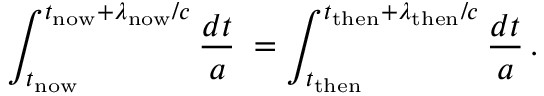Convert formula to latex. <formula><loc_0><loc_0><loc_500><loc_500>\int _ { t _ { n o w } } ^ { t _ { n o w } + \lambda _ { n o w } / c } { \frac { d t } { a } } \, = \int _ { t _ { t h e n } } ^ { t _ { t h e n } + \lambda _ { t h e n } / c } { \frac { d t } { a } } \, .</formula> 